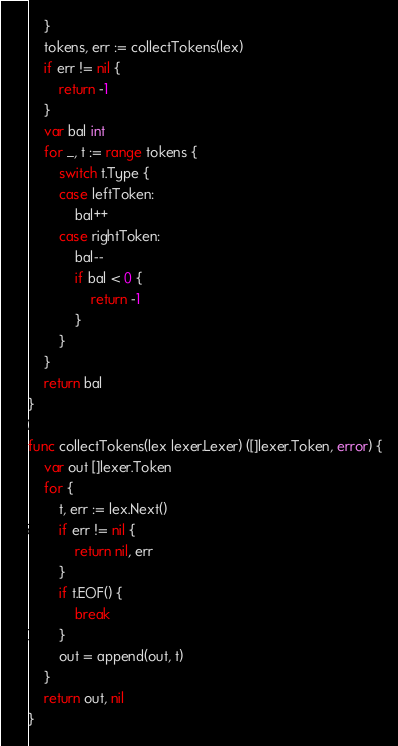<code> <loc_0><loc_0><loc_500><loc_500><_Go_>	}
	tokens, err := collectTokens(lex)
	if err != nil {
		return -1
	}
	var bal int
	for _, t := range tokens {
		switch t.Type {
		case leftToken:
			bal++
		case rightToken:
			bal--
			if bal < 0 {
				return -1
			}
		}
	}
	return bal
}

func collectTokens(lex lexer.Lexer) ([]lexer.Token, error) {
	var out []lexer.Token
	for {
		t, err := lex.Next()
		if err != nil {
			return nil, err
		}
		if t.EOF() {
			break
		}
		out = append(out, t)
	}
	return out, nil
}
</code> 